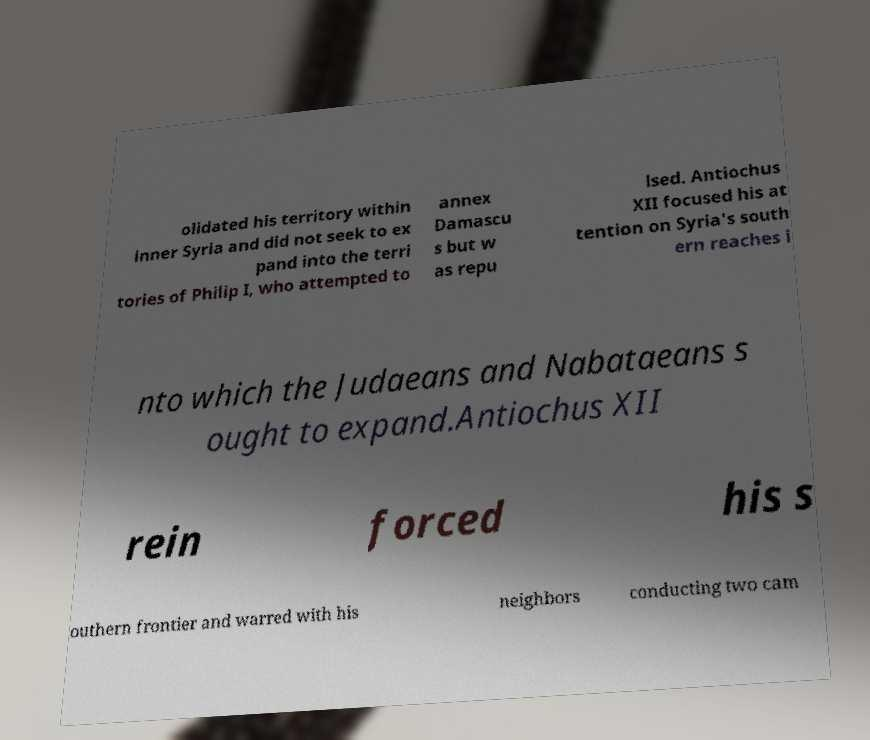Please identify and transcribe the text found in this image. olidated his territory within inner Syria and did not seek to ex pand into the terri tories of Philip I, who attempted to annex Damascu s but w as repu lsed. Antiochus XII focused his at tention on Syria's south ern reaches i nto which the Judaeans and Nabataeans s ought to expand.Antiochus XII rein forced his s outhern frontier and warred with his neighbors conducting two cam 